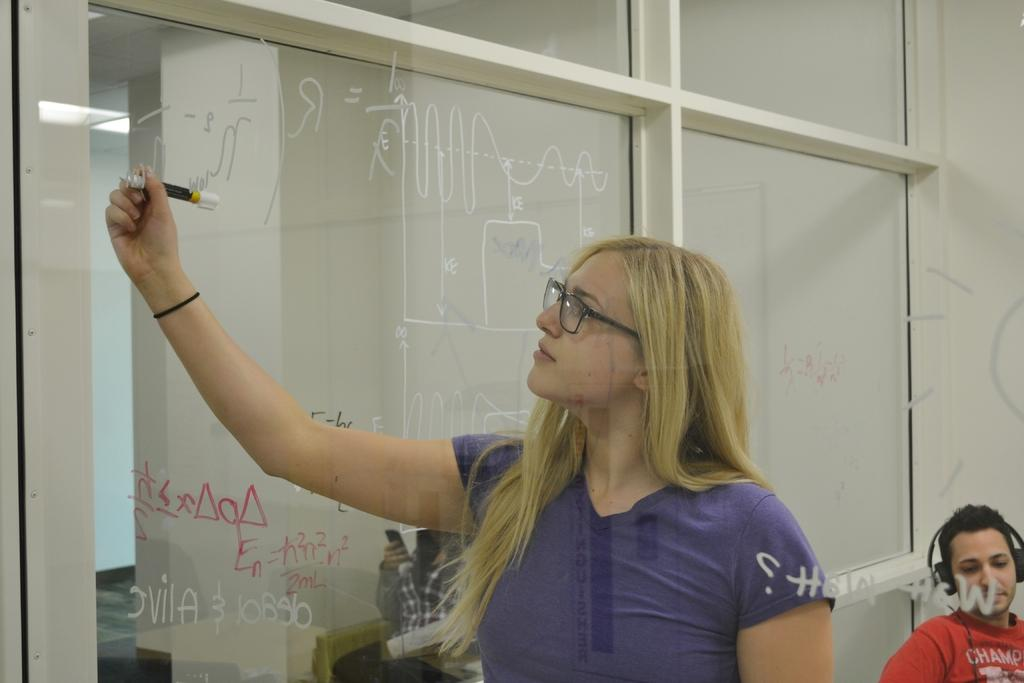What is the woman in the image doing? The woman is holding a sketch pen in the image. What can be seen on the woman's face? The woman is wearing spectacles in the image. What is visible in the background of the image? There is a wall, two people sitting, a mobile, and a headset in the background. What type of stamp can be seen on the woman's mouth in the image? There is no stamp visible on the woman's mouth in the image. What language is the woman speaking in the image? The image does not provide any information about the language being spoken by the woman. 